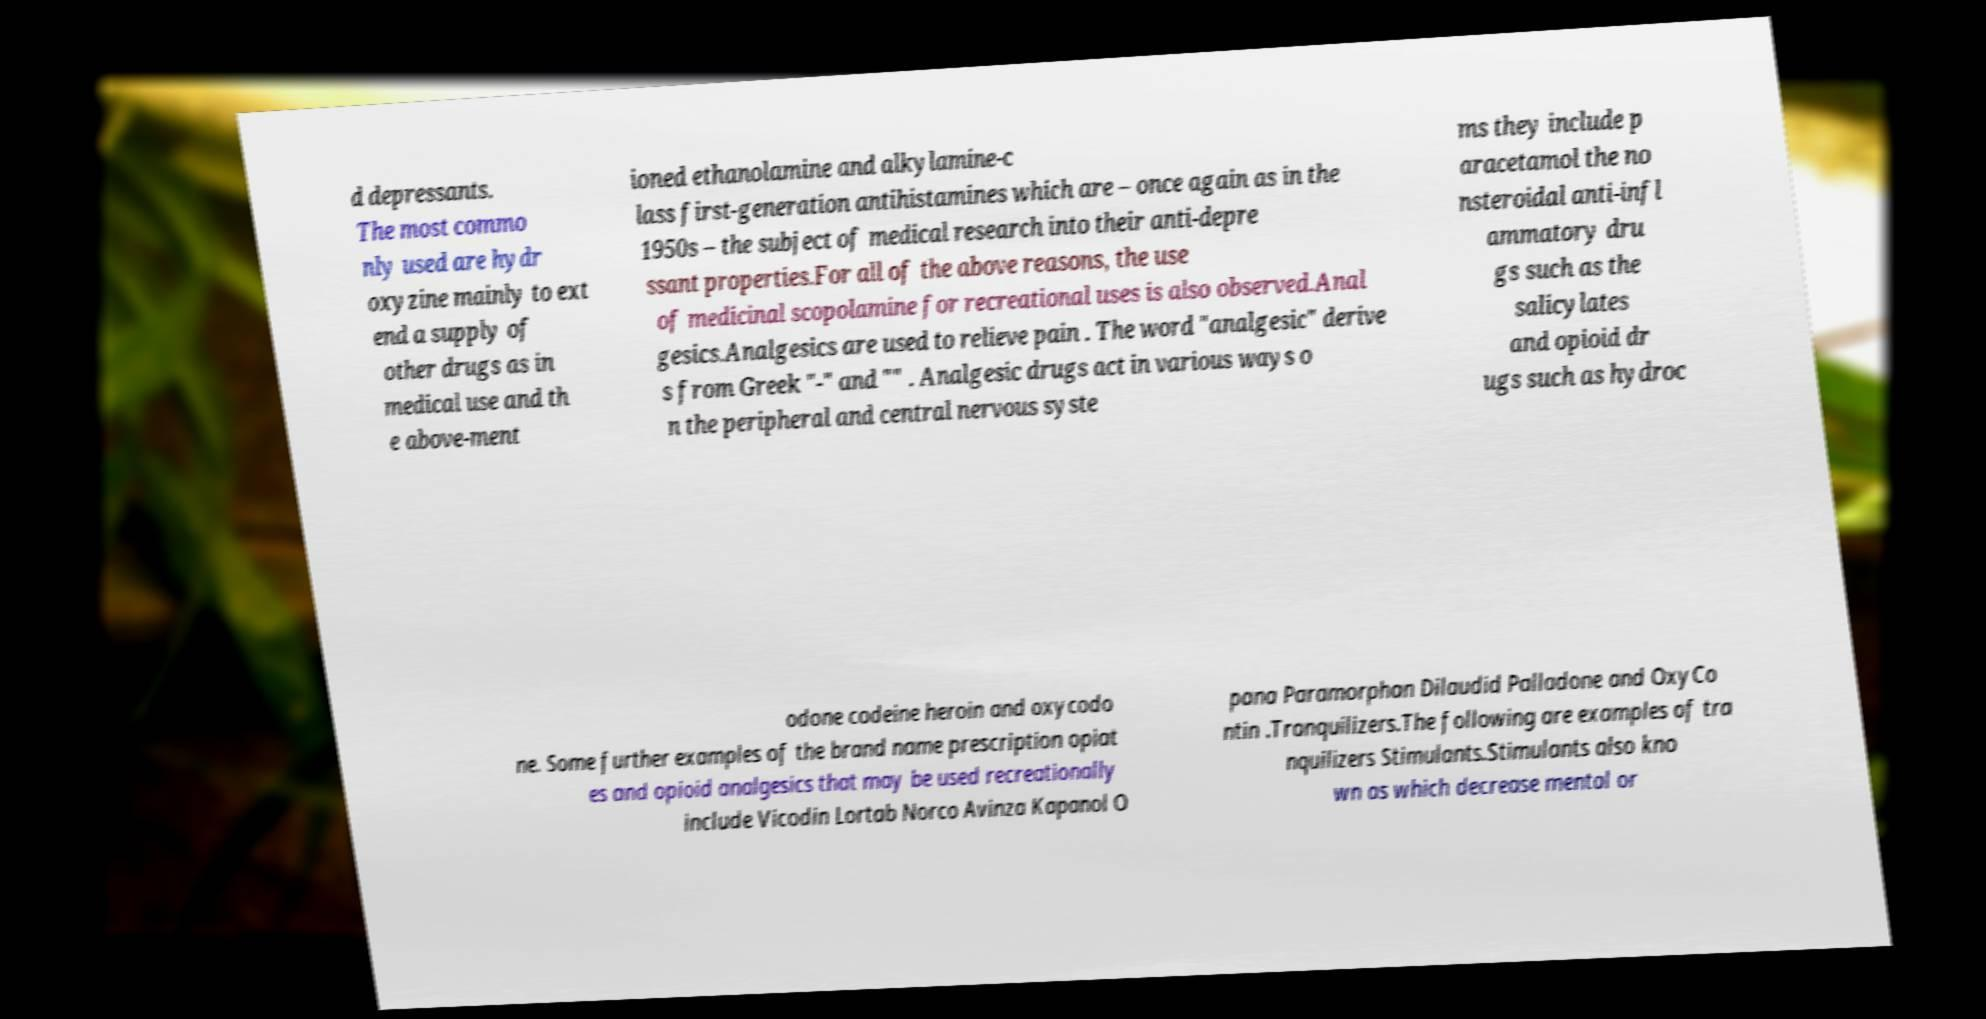Could you assist in decoding the text presented in this image and type it out clearly? d depressants. The most commo nly used are hydr oxyzine mainly to ext end a supply of other drugs as in medical use and th e above-ment ioned ethanolamine and alkylamine-c lass first-generation antihistamines which are – once again as in the 1950s – the subject of medical research into their anti-depre ssant properties.For all of the above reasons, the use of medicinal scopolamine for recreational uses is also observed.Anal gesics.Analgesics are used to relieve pain . The word "analgesic" derive s from Greek "-" and "" . Analgesic drugs act in various ways o n the peripheral and central nervous syste ms they include p aracetamol the no nsteroidal anti-infl ammatory dru gs such as the salicylates and opioid dr ugs such as hydroc odone codeine heroin and oxycodo ne. Some further examples of the brand name prescription opiat es and opioid analgesics that may be used recreationally include Vicodin Lortab Norco Avinza Kapanol O pana Paramorphan Dilaudid Palladone and OxyCo ntin .Tranquilizers.The following are examples of tra nquilizers Stimulants.Stimulants also kno wn as which decrease mental or 